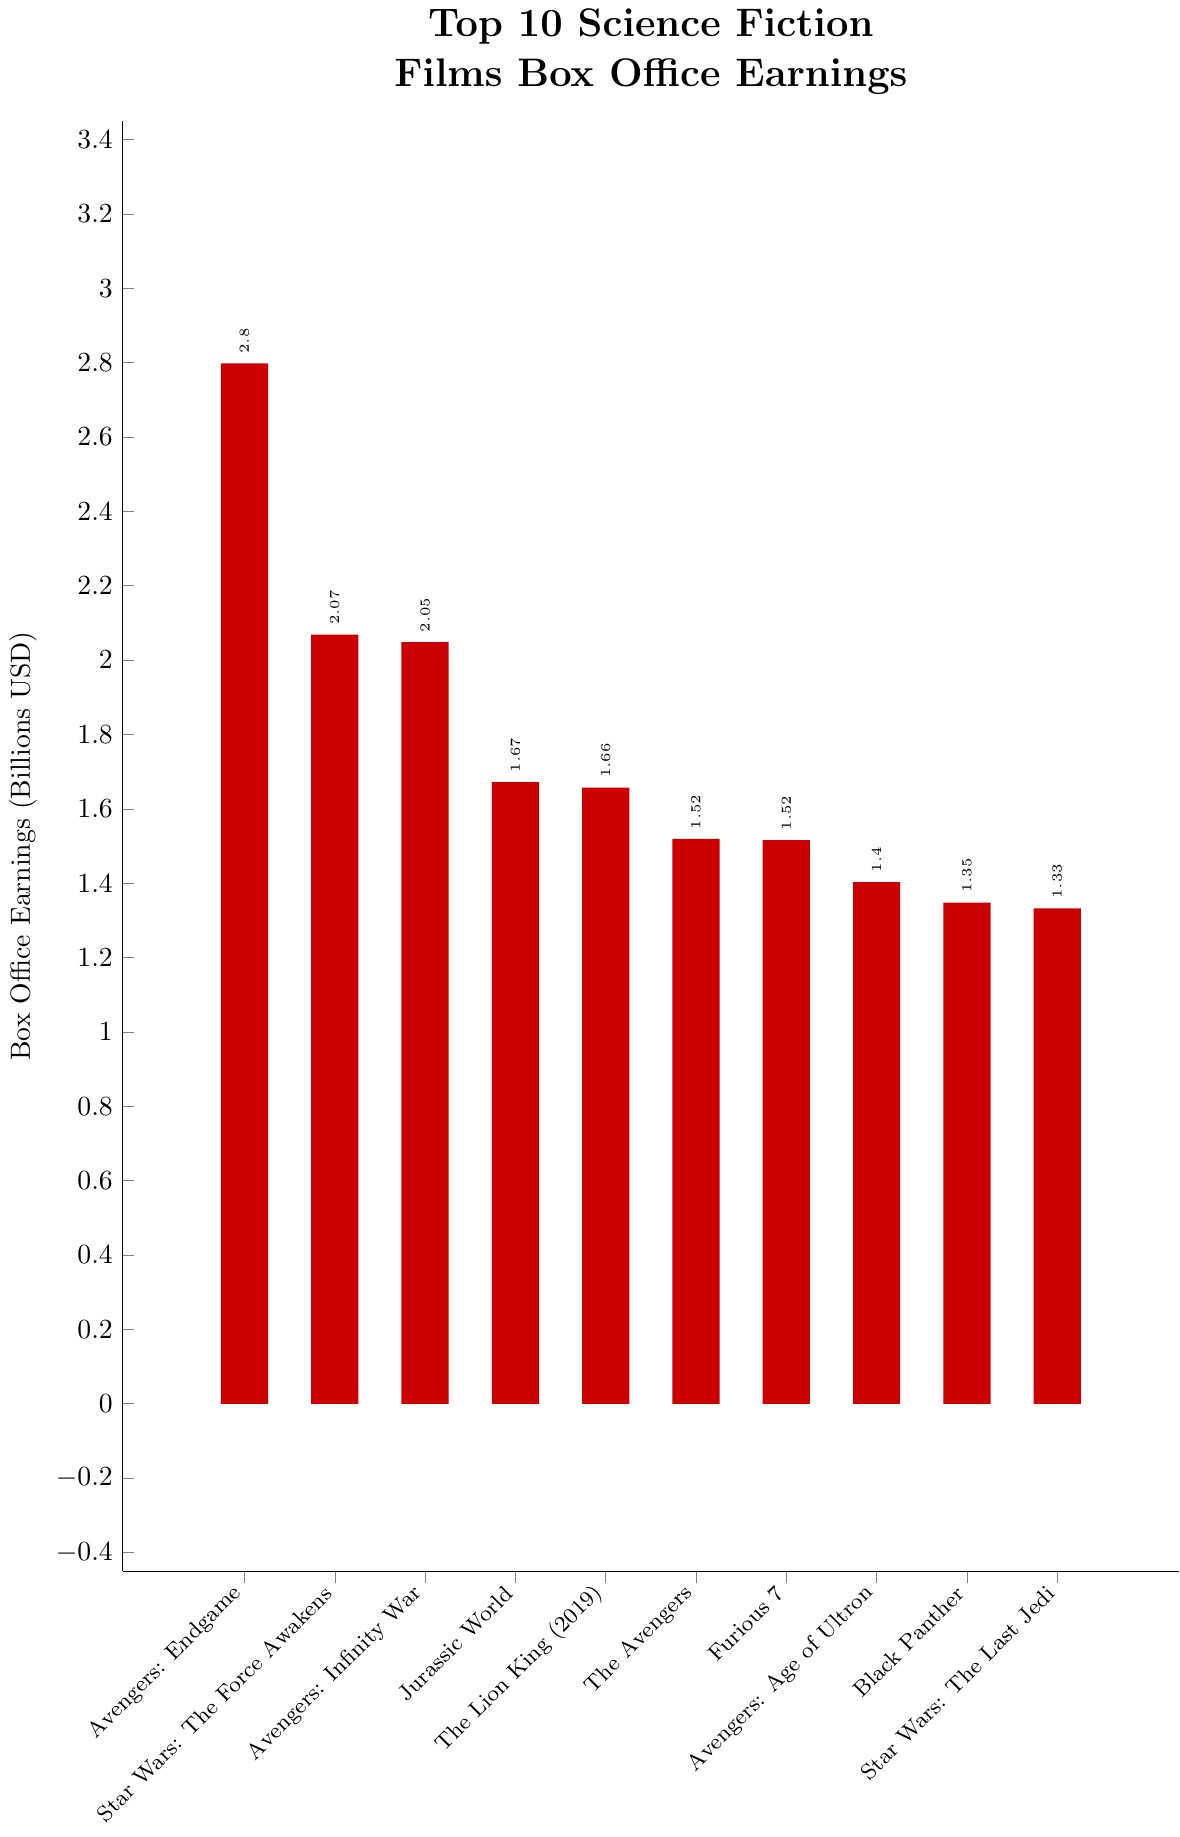What is the highest box office earnings among the top 10 science fiction films? The highest box office earnings among the top 10 films can be identified as the tallest bar in the graph. The title corresponding to the tallest bar is "Avengers: Endgame" with box office earnings of 2.7975 billion USD.
Answer: Avengers: Endgame, 2.7975 billion USD Which film has the second highest box office earnings? The second highest bar in the graph represents the film "Star Wars: The Force Awakens," indicating that it has the second highest box office earnings among the top 10 films.
Answer: Star Wars: The Force Awakens What is the total combined box office earnings of "Avengers: Endgame" and "Avengers: Infinity War"? To find the combined earnings, sum the box office earnings of "Avengers: Endgame" (2.7975 billion USD) and "Avengers: Infinity War" (2.0484 billion USD). The result is 2.7975 + 2.0484 = 4.8459 billion USD.
Answer: 4.8459 billion USD How much more did "Avengers: Endgame" earn compared to "Jurassic World"? Subtract the earnings of "Jurassic World" (1.6717 billion USD) from the earnings of "Avengers: Endgame" (2.7975 billion USD). The result is 2.7975 - 1.6717 = 1.1258 billion USD.
Answer: 1.1258 billion USD Which film earned more at the box office, "The Lion King (2019)" or "Black Panther"? Compare the heights of the bars for "The Lion King (2019)" and "Black Panther." "The Lion King (2019)" appears higher, indicating it earned more. "The Lion King (2019)" earned 1.6569 billion USD, while "Black Panther" earned 1.3473 billion USD.
Answer: The Lion King (2019) Which two films have the closest box office earnings among the top 10? Observe the heights of the bars and compare differences. The bars for "The Avengers" (1.5188 billion USD) and "Furious 7" (1.5160 billion USD) are closest in height, indicating their earnings are very close.
Answer: The Avengers and Furious 7 Approximately how much did all top 10 science fiction films earn in total? Sum the box office earnings of all top 10 films: (2.7975 + 2.0682 + 2.0484 + 1.6717 + 1.6569 + 1.5188 + 1.5160 + 1.4028 + 1.3473 + 1.3325) billion USD = 17.3601 billion USD.
Answer: 17.3601 billion USD Which film has the lowest box office earnings among the top 10? Identify the shortest bar in the graph to find the film with the lowest box office earnings. "Star Wars: The Last Jedi" has the lowest earnings among the top 10, with 1.3325 billion USD.
Answer: Star Wars: The Last Jedi By how much does the box office earnings of "Avengers: Age of Ultron" differ from "Black Panther"? Subtract "Black Panther's" earnings (1.3473 billion USD) from "Avengers: Age of Ultron's" earnings (1.4028 billion USD). The result is 1.4028 - 1.3473 = 0.0555 billion USD.
Answer: 0.0555 billion USD 